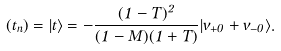Convert formula to latex. <formula><loc_0><loc_0><loc_500><loc_500>( t _ { n } ) = | t \rangle = - \frac { ( 1 - T ) ^ { 2 } } { ( 1 - M ) ( 1 + T ) } | v _ { + 0 } + v _ { - 0 } \rangle .</formula> 